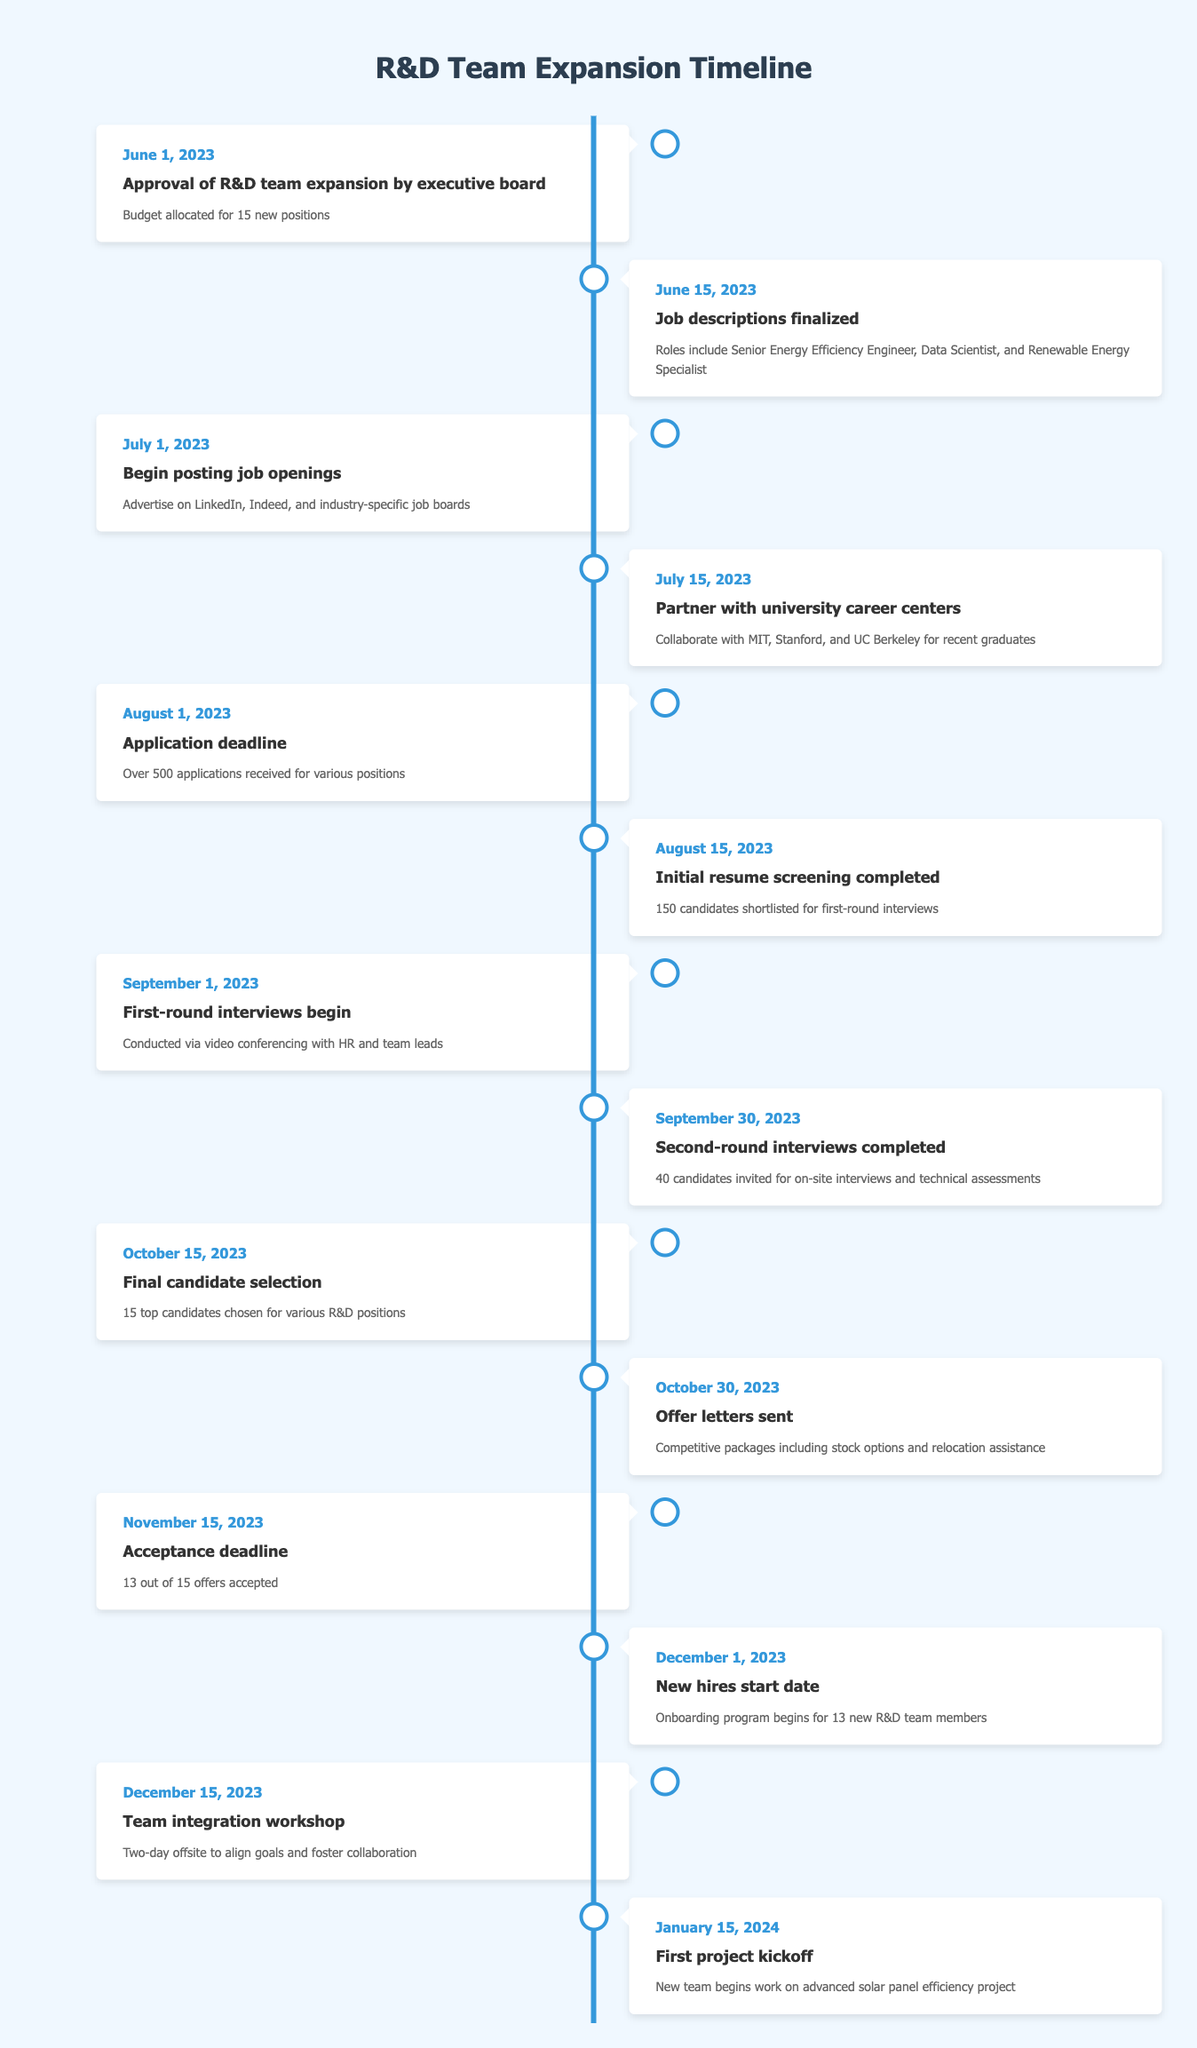What event occurred on July 1, 2023? The table shows that on July 1, 2023, the event "Begin posting job openings" took place.
Answer: Begin posting job openings How many applications were received by the application deadline on August 1, 2023? According to the table, over 500 applications were received by the application deadline.
Answer: Over 500 applications Was the initial resume screening completed before the application deadline? The table indicates that the initial resume screening was completed on August 15, which is after the application deadline of August 1.
Answer: No What is the time span between the final candidate selection and the acceptance deadline? The final candidate selection occurred on October 15, and the acceptance deadline was on November 15. The time span is 31 days (from October 15 to November 15).
Answer: 31 days How many candidates were invited for on-site interviews after the second-round interviews? The table states that 40 candidates were invited for on-site interviews after the second-round interviews were completed on September 30.
Answer: 40 candidates Did all offer letters sent out result in accepted job offers? The table notes that 13 out of 15 offers were accepted, indicating that not all offers resulted in accepted job offers.
Answer: No What percentage of total job offers were accepted by the acceptance deadline? The total number of offers sent was 15, and 13 were accepted. The percentage is calculated as (13/15)*100, which equals approximately 86.67%.
Answer: Approximately 86.67% Which roles were included in the finalized job descriptions, and when were they finalized? The job descriptions, finalized on June 15, 2023, included positions for Senior Energy Efficiency Engineer, Data Scientist, and Renewable Energy Specialist.
Answer: Senior Energy Efficiency Engineer, Data Scientist, and Renewable Energy Specialist What is the date of the first project kickoff after new hires started? The first project kickoff is on January 15, 2024, which is after the new hires started on December 1, 2023.
Answer: January 15, 2024 